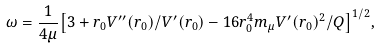<formula> <loc_0><loc_0><loc_500><loc_500>\omega = \frac { 1 } { 4 \mu } { \left [ 3 + r _ { 0 } V ^ { \prime \prime } ( r _ { 0 } ) / V ^ { \prime } ( r _ { 0 } ) - 1 6 r _ { 0 } ^ { 4 } m _ { \mu } V ^ { \prime } ( r _ { 0 } ) ^ { 2 } / Q \right ] } ^ { 1 / 2 } ,</formula> 